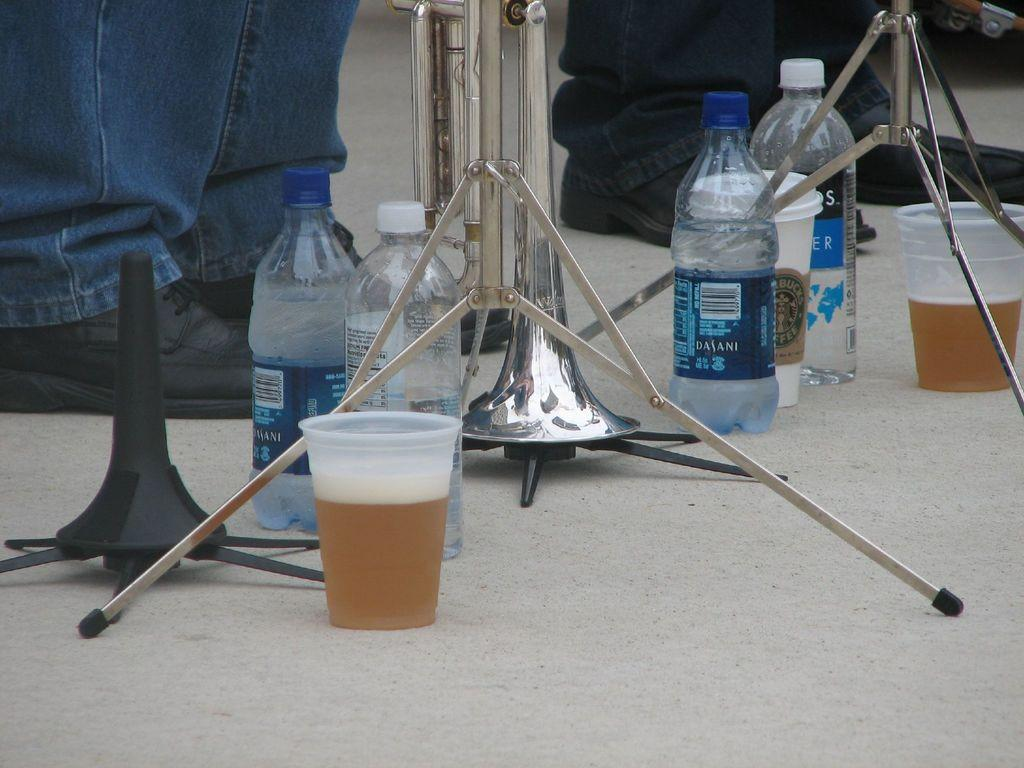<image>
Describe the image concisely. A water bottle on the ground with Dasani on it. 